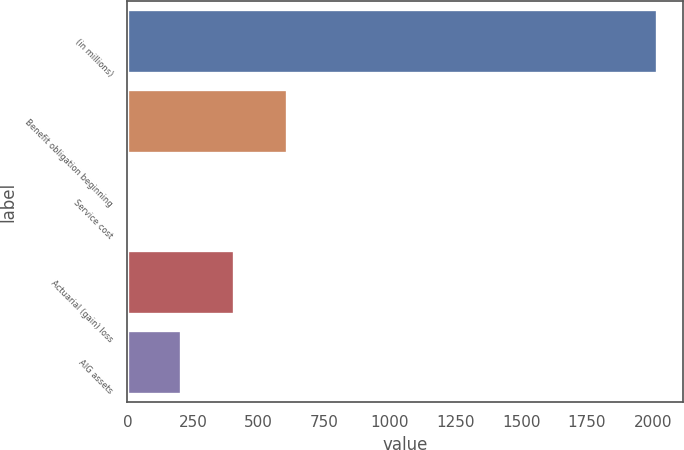<chart> <loc_0><loc_0><loc_500><loc_500><bar_chart><fcel>(in millions)<fcel>Benefit obligation beginning<fcel>Service cost<fcel>Actuarial (gain) loss<fcel>AIG assets<nl><fcel>2015<fcel>608<fcel>5<fcel>407<fcel>206<nl></chart> 